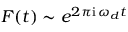Convert formula to latex. <formula><loc_0><loc_0><loc_500><loc_500>F ( t ) \sim e ^ { 2 \pi i \, \omega _ { d } t }</formula> 